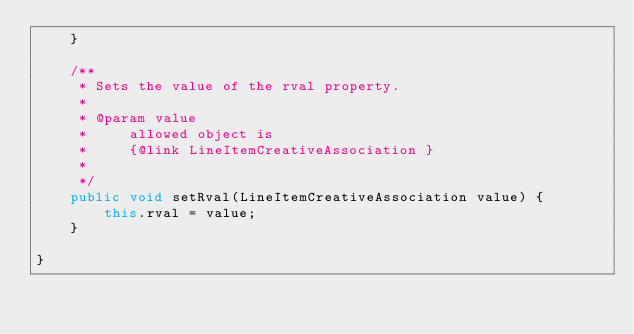Convert code to text. <code><loc_0><loc_0><loc_500><loc_500><_Java_>    }

    /**
     * Sets the value of the rval property.
     * 
     * @param value
     *     allowed object is
     *     {@link LineItemCreativeAssociation }
     *     
     */
    public void setRval(LineItemCreativeAssociation value) {
        this.rval = value;
    }

}
</code> 